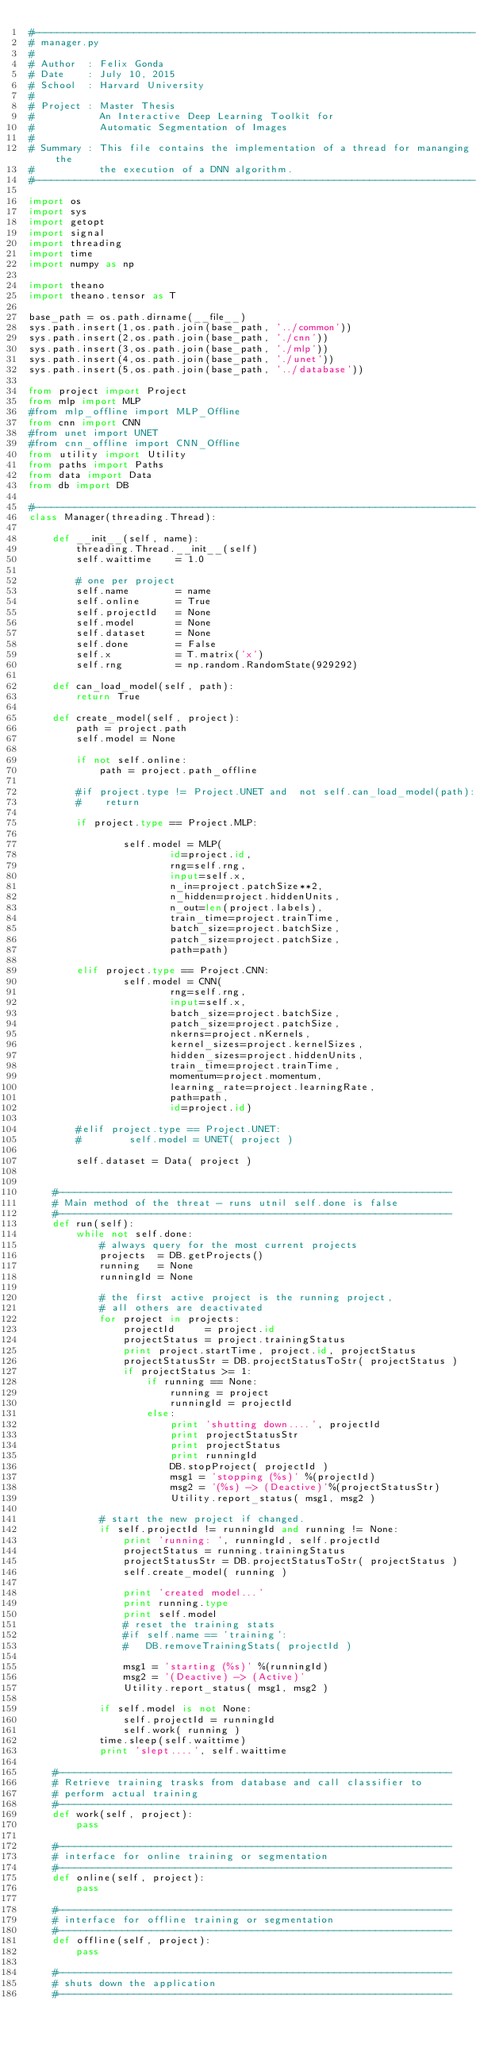Convert code to text. <code><loc_0><loc_0><loc_500><loc_500><_Python_>#---------------------------------------------------------------------------
# manager.py
#
# Author  : Felix Gonda
# Date    : July 10, 2015
# School  : Harvard University
#
# Project : Master Thesis
#           An Interactive Deep Learning Toolkit for
#           Automatic Segmentation of Images
#
# Summary : This file contains the implementation of a thread for mananging the 
#           the execution of a DNN algorithm.  
#---------------------------------------------------------------------------

import os
import sys
import getopt
import signal
import threading
import time
import numpy as np

import theano
import theano.tensor as T

base_path = os.path.dirname(__file__)
sys.path.insert(1,os.path.join(base_path, '../common'))
sys.path.insert(2,os.path.join(base_path, './cnn'))
sys.path.insert(3,os.path.join(base_path, './mlp'))
sys.path.insert(4,os.path.join(base_path, './unet'))
sys.path.insert(5,os.path.join(base_path, '../database'))

from project import Project
from mlp import MLP 
#from mlp_offline import MLP_Offline
from cnn import CNN
#from unet import UNET
#from cnn_offline import CNN_Offline
from utility import Utility
from paths import Paths
from data import Data
from db import DB

#---------------------------------------------------------------------------
class Manager(threading.Thread):

    def __init__(self, name):
        threading.Thread.__init__(self)
        self.waittime    = 1.0

        # one per project
        self.name        = name
        self.online      = True
        self.projectId   = None
        self.model       = None
        self.dataset     = None
        self.done        = False
        self.x           = T.matrix('x')
        self.rng         = np.random.RandomState(929292)

    def can_load_model(self, path):
        return True

    def create_model(self, project):
        path = project.path
        self.model = None

        if not self.online:
            path = project.path_offline

        #if project.type != Project.UNET and  not self.can_load_model(path):
        #    return

        if project.type == Project.MLP:

                self.model = MLP(
                        id=project.id,
                        rng=self.rng,
                        input=self.x,
                        n_in=project.patchSize**2,
                        n_hidden=project.hiddenUnits,
                        n_out=len(project.labels),
                        train_time=project.trainTime,
                        batch_size=project.batchSize,
                        patch_size=project.patchSize,
                        path=path)

        elif project.type == Project.CNN:
                self.model = CNN(
                        rng=self.rng,
                        input=self.x,
                        batch_size=project.batchSize,
                        patch_size=project.patchSize,
                        nkerns=project.nKernels,
                        kernel_sizes=project.kernelSizes,
                        hidden_sizes=project.hiddenUnits,
                        train_time=project.trainTime,
                        momentum=project.momentum,
                        learning_rate=project.learningRate,
                        path=path,
                        id=project.id)

        #elif project.type == Project.UNET:
        #        self.model = UNET( project )

        self.dataset = Data( project )


    #-------------------------------------------------------------------
    # Main method of the threat - runs utnil self.done is false
    #-------------------------------------------------------------------
    def run(self):
        while not self.done: 
            # always query for the most current projects
            projects  = DB.getProjects()
            running   = None
            runningId = None

            # the first active project is the running project,
            # all others are deactivated 
            for project in projects:
                projectId     = project.id
                projectStatus = project.trainingStatus
                print project.startTime, project.id, projectStatus
                projectStatusStr = DB.projectStatusToStr( projectStatus )
                if projectStatus >= 1:
                    if running == None:
                        running = project
                        runningId = projectId
                    else:
                        print 'shutting down....', projectId
                        print projectStatusStr
                        print projectStatus
                        print runningId
                        DB.stopProject( projectId )
                        msg1 = 'stopping (%s)' %(projectId)
                        msg2 = '(%s) -> (Deactive)'%(projectStatusStr)
                        Utility.report_status( msg1, msg2 )

            # start the new project if changed.
            if self.projectId != runningId and running != None:
                print 'running: ', runningId, self.projectId 
                projectStatus = running.trainingStatus
                projectStatusStr = DB.projectStatusToStr( projectStatus )
                self.create_model( running )

                print 'created model...'
                print running.type
                print self.model
                # reset the training stats
                #if self.name == 'training':
                #	DB.removeTrainingStats( projectId )

                msg1 = 'starting (%s)' %(runningId)
                msg2 = '(Deactive) -> (Active)'
                Utility.report_status( msg1, msg2 )

            if self.model is not None:
                self.projectId = runningId
                self.work( running )
            time.sleep(self.waittime)
            print 'slept....', self.waittime

    #-------------------------------------------------------------------
    # Retrieve training trasks from database and call classifier to
    # perform actual training
    #-------------------------------------------------------------------
    def work(self, project):
        pass

    #-------------------------------------------------------------------
    # interface for online training or segmentation
    #-------------------------------------------------------------------
    def online(self, project):
        pass

    #-------------------------------------------------------------------
    # interface for offline training or segmentation
    #-------------------------------------------------------------------
    def offline(self, project):
        pass

    #-------------------------------------------------------------------
    # shuts down the application
    #-------------------------------------------------------------------</code> 